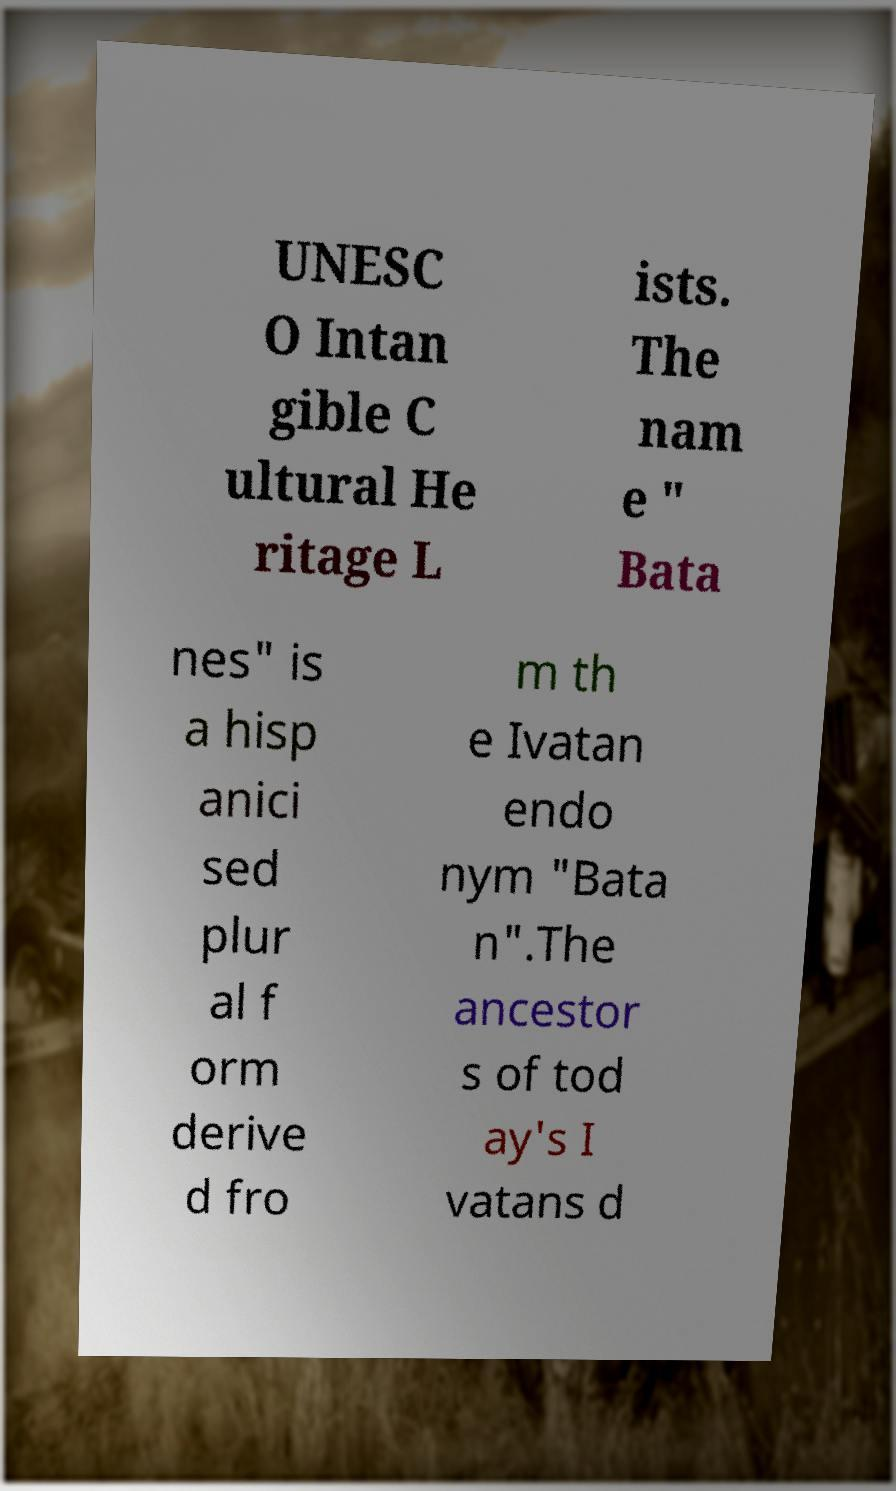For documentation purposes, I need the text within this image transcribed. Could you provide that? UNESC O Intan gible C ultural He ritage L ists. The nam e " Bata nes" is a hisp anici sed plur al f orm derive d fro m th e Ivatan endo nym "Bata n".The ancestor s of tod ay's I vatans d 